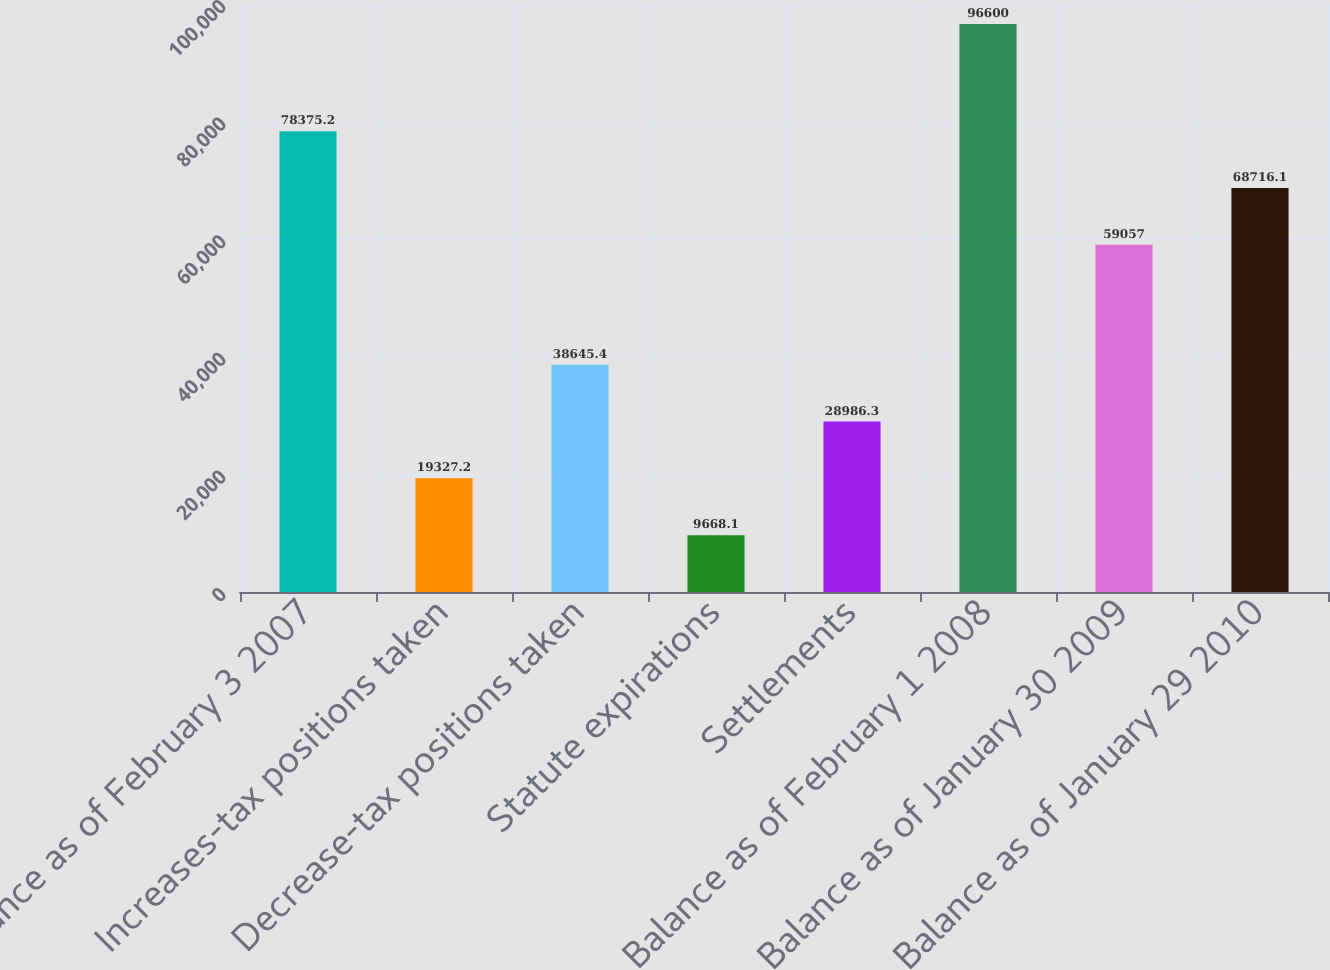<chart> <loc_0><loc_0><loc_500><loc_500><bar_chart><fcel>Balance as of February 3 2007<fcel>Increases-tax positions taken<fcel>Decrease-tax positions taken<fcel>Statute expirations<fcel>Settlements<fcel>Balance as of February 1 2008<fcel>Balance as of January 30 2009<fcel>Balance as of January 29 2010<nl><fcel>78375.2<fcel>19327.2<fcel>38645.4<fcel>9668.1<fcel>28986.3<fcel>96600<fcel>59057<fcel>68716.1<nl></chart> 